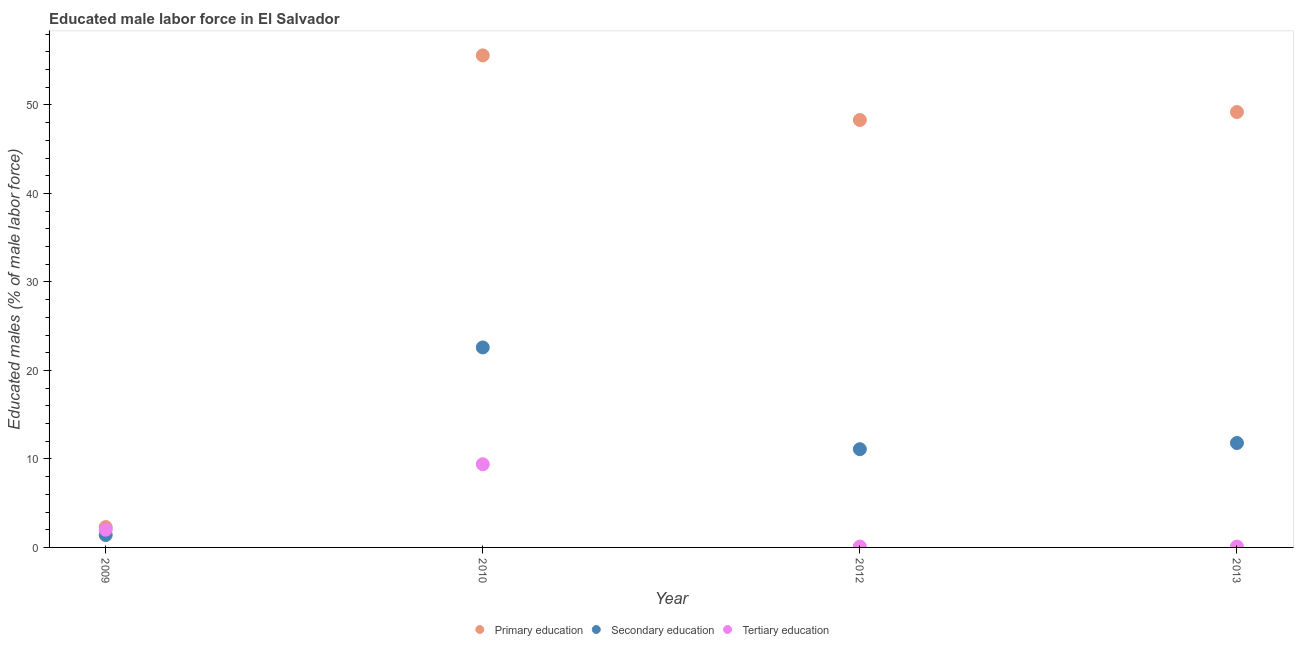Is the number of dotlines equal to the number of legend labels?
Keep it short and to the point. Yes. What is the percentage of male labor force who received primary education in 2013?
Offer a very short reply. 49.2. Across all years, what is the maximum percentage of male labor force who received secondary education?
Keep it short and to the point. 22.6. Across all years, what is the minimum percentage of male labor force who received primary education?
Ensure brevity in your answer.  2.3. What is the total percentage of male labor force who received tertiary education in the graph?
Ensure brevity in your answer.  11.6. What is the difference between the percentage of male labor force who received tertiary education in 2012 and that in 2013?
Make the answer very short. 0. What is the difference between the percentage of male labor force who received tertiary education in 2010 and the percentage of male labor force who received primary education in 2013?
Offer a terse response. -39.8. What is the average percentage of male labor force who received tertiary education per year?
Make the answer very short. 2.9. In the year 2012, what is the difference between the percentage of male labor force who received tertiary education and percentage of male labor force who received secondary education?
Provide a succinct answer. -11. What is the ratio of the percentage of male labor force who received secondary education in 2009 to that in 2012?
Your answer should be compact. 0.13. Is the difference between the percentage of male labor force who received tertiary education in 2012 and 2013 greater than the difference between the percentage of male labor force who received primary education in 2012 and 2013?
Offer a terse response. Yes. What is the difference between the highest and the second highest percentage of male labor force who received tertiary education?
Provide a short and direct response. 7.4. What is the difference between the highest and the lowest percentage of male labor force who received tertiary education?
Provide a succinct answer. 9.3. In how many years, is the percentage of male labor force who received tertiary education greater than the average percentage of male labor force who received tertiary education taken over all years?
Offer a very short reply. 1. Is the sum of the percentage of male labor force who received tertiary education in 2009 and 2012 greater than the maximum percentage of male labor force who received secondary education across all years?
Offer a very short reply. No. Is it the case that in every year, the sum of the percentage of male labor force who received primary education and percentage of male labor force who received secondary education is greater than the percentage of male labor force who received tertiary education?
Your answer should be compact. Yes. Does the percentage of male labor force who received secondary education monotonically increase over the years?
Provide a short and direct response. No. Is the percentage of male labor force who received tertiary education strictly less than the percentage of male labor force who received secondary education over the years?
Ensure brevity in your answer.  No. How many dotlines are there?
Offer a very short reply. 3. How many years are there in the graph?
Make the answer very short. 4. Does the graph contain any zero values?
Provide a short and direct response. No. Does the graph contain grids?
Your answer should be compact. No. Where does the legend appear in the graph?
Ensure brevity in your answer.  Bottom center. How many legend labels are there?
Provide a short and direct response. 3. What is the title of the graph?
Ensure brevity in your answer.  Educated male labor force in El Salvador. What is the label or title of the X-axis?
Keep it short and to the point. Year. What is the label or title of the Y-axis?
Provide a succinct answer. Educated males (% of male labor force). What is the Educated males (% of male labor force) of Primary education in 2009?
Make the answer very short. 2.3. What is the Educated males (% of male labor force) of Secondary education in 2009?
Your answer should be very brief. 1.4. What is the Educated males (% of male labor force) in Primary education in 2010?
Your answer should be compact. 55.6. What is the Educated males (% of male labor force) of Secondary education in 2010?
Your answer should be very brief. 22.6. What is the Educated males (% of male labor force) of Tertiary education in 2010?
Your answer should be very brief. 9.4. What is the Educated males (% of male labor force) in Primary education in 2012?
Your answer should be very brief. 48.3. What is the Educated males (% of male labor force) in Secondary education in 2012?
Offer a very short reply. 11.1. What is the Educated males (% of male labor force) in Tertiary education in 2012?
Provide a short and direct response. 0.1. What is the Educated males (% of male labor force) of Primary education in 2013?
Provide a succinct answer. 49.2. What is the Educated males (% of male labor force) in Secondary education in 2013?
Provide a short and direct response. 11.8. What is the Educated males (% of male labor force) in Tertiary education in 2013?
Keep it short and to the point. 0.1. Across all years, what is the maximum Educated males (% of male labor force) in Primary education?
Give a very brief answer. 55.6. Across all years, what is the maximum Educated males (% of male labor force) of Secondary education?
Your answer should be very brief. 22.6. Across all years, what is the maximum Educated males (% of male labor force) in Tertiary education?
Your response must be concise. 9.4. Across all years, what is the minimum Educated males (% of male labor force) of Primary education?
Give a very brief answer. 2.3. Across all years, what is the minimum Educated males (% of male labor force) of Secondary education?
Your response must be concise. 1.4. Across all years, what is the minimum Educated males (% of male labor force) in Tertiary education?
Your answer should be very brief. 0.1. What is the total Educated males (% of male labor force) in Primary education in the graph?
Your answer should be very brief. 155.4. What is the total Educated males (% of male labor force) of Secondary education in the graph?
Ensure brevity in your answer.  46.9. What is the total Educated males (% of male labor force) in Tertiary education in the graph?
Offer a terse response. 11.6. What is the difference between the Educated males (% of male labor force) of Primary education in 2009 and that in 2010?
Provide a short and direct response. -53.3. What is the difference between the Educated males (% of male labor force) in Secondary education in 2009 and that in 2010?
Your answer should be very brief. -21.2. What is the difference between the Educated males (% of male labor force) in Tertiary education in 2009 and that in 2010?
Keep it short and to the point. -7.4. What is the difference between the Educated males (% of male labor force) in Primary education in 2009 and that in 2012?
Offer a terse response. -46. What is the difference between the Educated males (% of male labor force) of Secondary education in 2009 and that in 2012?
Offer a terse response. -9.7. What is the difference between the Educated males (% of male labor force) of Tertiary education in 2009 and that in 2012?
Your answer should be very brief. 1.9. What is the difference between the Educated males (% of male labor force) in Primary education in 2009 and that in 2013?
Offer a very short reply. -46.9. What is the difference between the Educated males (% of male labor force) in Secondary education in 2009 and that in 2013?
Offer a very short reply. -10.4. What is the difference between the Educated males (% of male labor force) of Primary education in 2010 and that in 2012?
Your answer should be compact. 7.3. What is the difference between the Educated males (% of male labor force) of Secondary education in 2010 and that in 2012?
Keep it short and to the point. 11.5. What is the difference between the Educated males (% of male labor force) of Primary education in 2012 and that in 2013?
Offer a terse response. -0.9. What is the difference between the Educated males (% of male labor force) in Primary education in 2009 and the Educated males (% of male labor force) in Secondary education in 2010?
Your response must be concise. -20.3. What is the difference between the Educated males (% of male labor force) in Primary education in 2009 and the Educated males (% of male labor force) in Tertiary education in 2010?
Keep it short and to the point. -7.1. What is the difference between the Educated males (% of male labor force) of Primary education in 2009 and the Educated males (% of male labor force) of Secondary education in 2012?
Provide a succinct answer. -8.8. What is the difference between the Educated males (% of male labor force) in Primary education in 2009 and the Educated males (% of male labor force) in Tertiary education in 2012?
Your answer should be very brief. 2.2. What is the difference between the Educated males (% of male labor force) of Secondary education in 2009 and the Educated males (% of male labor force) of Tertiary education in 2012?
Ensure brevity in your answer.  1.3. What is the difference between the Educated males (% of male labor force) of Primary education in 2010 and the Educated males (% of male labor force) of Secondary education in 2012?
Your answer should be compact. 44.5. What is the difference between the Educated males (% of male labor force) of Primary education in 2010 and the Educated males (% of male labor force) of Tertiary education in 2012?
Offer a very short reply. 55.5. What is the difference between the Educated males (% of male labor force) of Primary education in 2010 and the Educated males (% of male labor force) of Secondary education in 2013?
Offer a very short reply. 43.8. What is the difference between the Educated males (% of male labor force) in Primary education in 2010 and the Educated males (% of male labor force) in Tertiary education in 2013?
Give a very brief answer. 55.5. What is the difference between the Educated males (% of male labor force) of Secondary education in 2010 and the Educated males (% of male labor force) of Tertiary education in 2013?
Make the answer very short. 22.5. What is the difference between the Educated males (% of male labor force) in Primary education in 2012 and the Educated males (% of male labor force) in Secondary education in 2013?
Your answer should be very brief. 36.5. What is the difference between the Educated males (% of male labor force) of Primary education in 2012 and the Educated males (% of male labor force) of Tertiary education in 2013?
Your answer should be very brief. 48.2. What is the difference between the Educated males (% of male labor force) of Secondary education in 2012 and the Educated males (% of male labor force) of Tertiary education in 2013?
Your answer should be very brief. 11. What is the average Educated males (% of male labor force) of Primary education per year?
Keep it short and to the point. 38.85. What is the average Educated males (% of male labor force) of Secondary education per year?
Your response must be concise. 11.72. In the year 2009, what is the difference between the Educated males (% of male labor force) of Primary education and Educated males (% of male labor force) of Secondary education?
Your answer should be very brief. 0.9. In the year 2010, what is the difference between the Educated males (% of male labor force) in Primary education and Educated males (% of male labor force) in Secondary education?
Ensure brevity in your answer.  33. In the year 2010, what is the difference between the Educated males (% of male labor force) in Primary education and Educated males (% of male labor force) in Tertiary education?
Give a very brief answer. 46.2. In the year 2012, what is the difference between the Educated males (% of male labor force) of Primary education and Educated males (% of male labor force) of Secondary education?
Your response must be concise. 37.2. In the year 2012, what is the difference between the Educated males (% of male labor force) of Primary education and Educated males (% of male labor force) of Tertiary education?
Make the answer very short. 48.2. In the year 2013, what is the difference between the Educated males (% of male labor force) in Primary education and Educated males (% of male labor force) in Secondary education?
Provide a short and direct response. 37.4. In the year 2013, what is the difference between the Educated males (% of male labor force) in Primary education and Educated males (% of male labor force) in Tertiary education?
Your response must be concise. 49.1. What is the ratio of the Educated males (% of male labor force) in Primary education in 2009 to that in 2010?
Ensure brevity in your answer.  0.04. What is the ratio of the Educated males (% of male labor force) in Secondary education in 2009 to that in 2010?
Ensure brevity in your answer.  0.06. What is the ratio of the Educated males (% of male labor force) of Tertiary education in 2009 to that in 2010?
Your answer should be compact. 0.21. What is the ratio of the Educated males (% of male labor force) in Primary education in 2009 to that in 2012?
Your answer should be very brief. 0.05. What is the ratio of the Educated males (% of male labor force) of Secondary education in 2009 to that in 2012?
Ensure brevity in your answer.  0.13. What is the ratio of the Educated males (% of male labor force) in Tertiary education in 2009 to that in 2012?
Provide a succinct answer. 20. What is the ratio of the Educated males (% of male labor force) in Primary education in 2009 to that in 2013?
Your response must be concise. 0.05. What is the ratio of the Educated males (% of male labor force) in Secondary education in 2009 to that in 2013?
Provide a short and direct response. 0.12. What is the ratio of the Educated males (% of male labor force) in Tertiary education in 2009 to that in 2013?
Your response must be concise. 20. What is the ratio of the Educated males (% of male labor force) in Primary education in 2010 to that in 2012?
Provide a succinct answer. 1.15. What is the ratio of the Educated males (% of male labor force) of Secondary education in 2010 to that in 2012?
Your answer should be very brief. 2.04. What is the ratio of the Educated males (% of male labor force) in Tertiary education in 2010 to that in 2012?
Give a very brief answer. 94. What is the ratio of the Educated males (% of male labor force) of Primary education in 2010 to that in 2013?
Your answer should be very brief. 1.13. What is the ratio of the Educated males (% of male labor force) in Secondary education in 2010 to that in 2013?
Your answer should be very brief. 1.92. What is the ratio of the Educated males (% of male labor force) of Tertiary education in 2010 to that in 2013?
Your response must be concise. 94. What is the ratio of the Educated males (% of male labor force) in Primary education in 2012 to that in 2013?
Your answer should be compact. 0.98. What is the ratio of the Educated males (% of male labor force) of Secondary education in 2012 to that in 2013?
Make the answer very short. 0.94. What is the ratio of the Educated males (% of male labor force) of Tertiary education in 2012 to that in 2013?
Ensure brevity in your answer.  1. What is the difference between the highest and the lowest Educated males (% of male labor force) in Primary education?
Make the answer very short. 53.3. What is the difference between the highest and the lowest Educated males (% of male labor force) in Secondary education?
Your response must be concise. 21.2. What is the difference between the highest and the lowest Educated males (% of male labor force) of Tertiary education?
Keep it short and to the point. 9.3. 